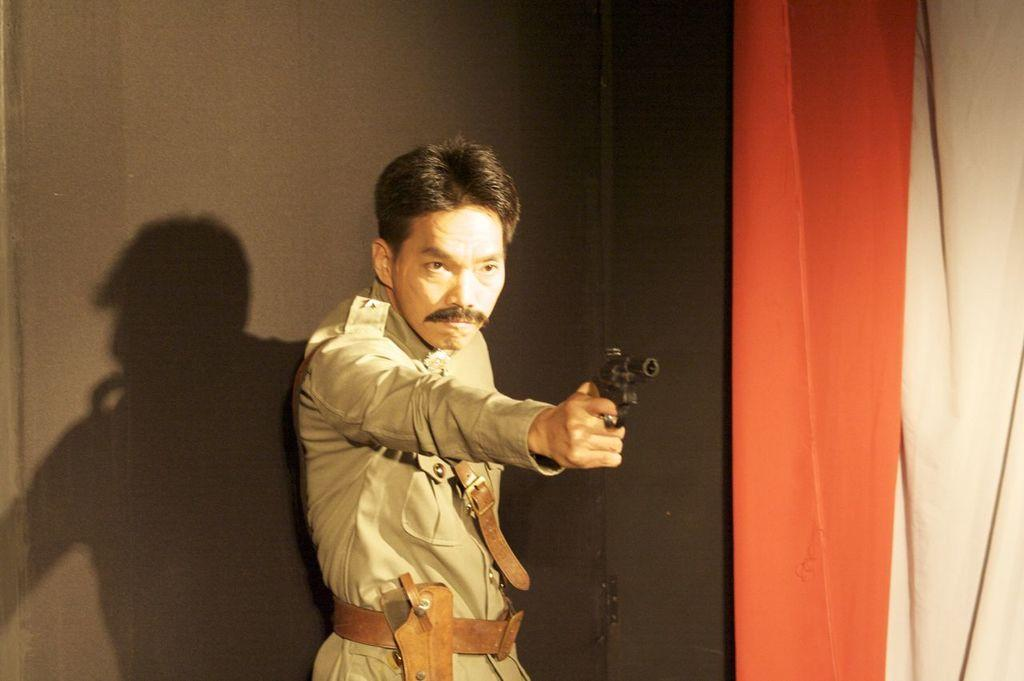What is the main subject of the image? The main subject of the image is a man. What is the man wearing in the image? The man is wearing a police uniform in the image. What object is the man holding in the image? The man is holding a gun in the image. How many children are playing in the store in the image? There is no store or children present in the image; it features a man in a police uniform holding a gun. What type of hat is the fireman wearing in the image? There is no fireman present in the image; it features a man in a police uniform holding a gun. 